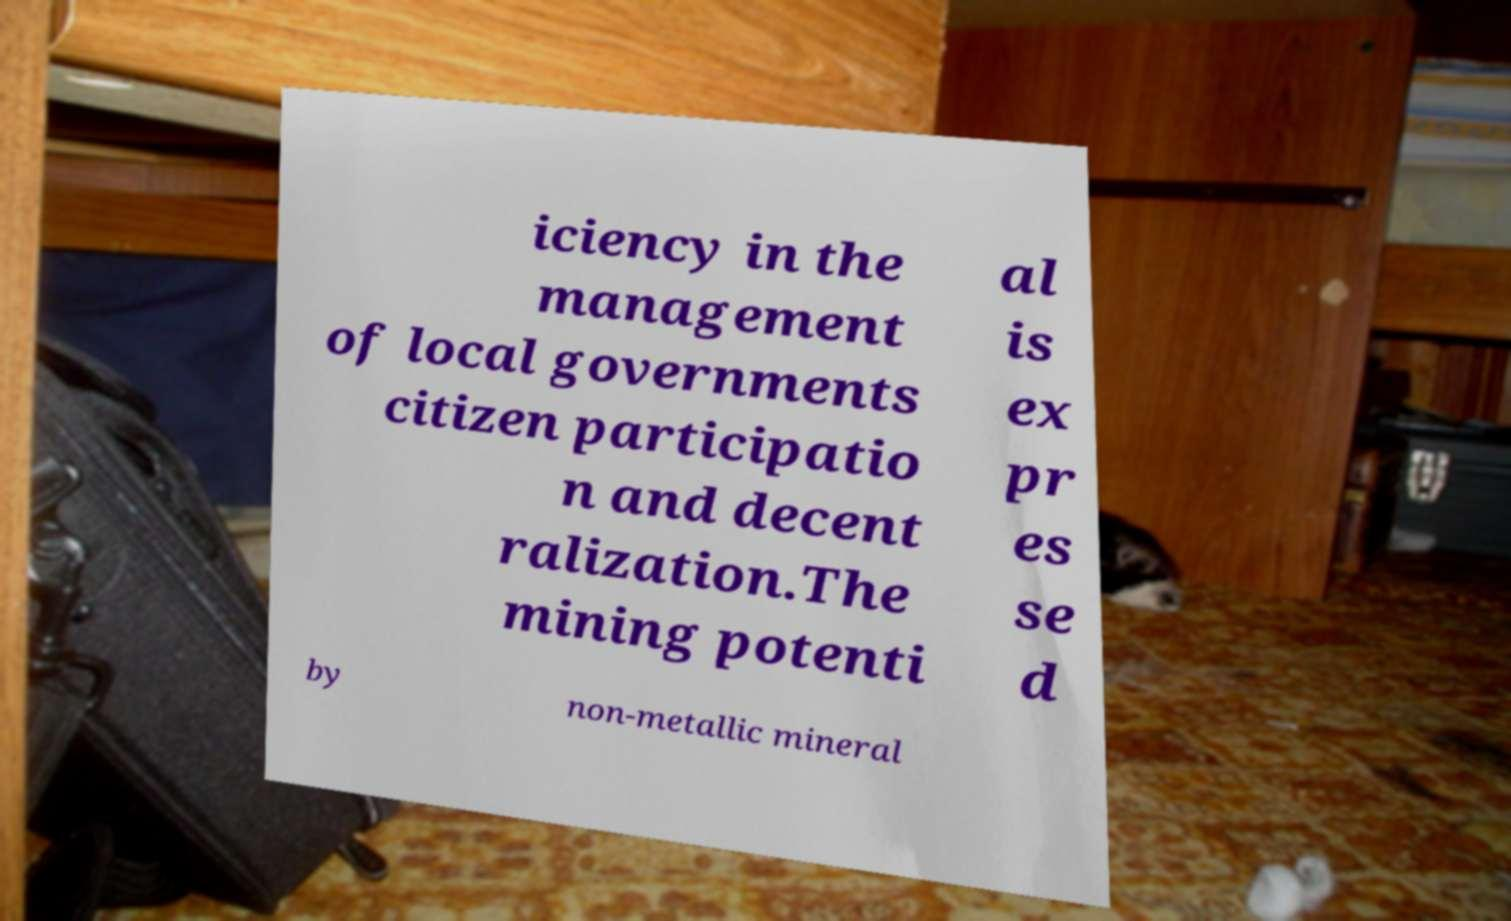Can you accurately transcribe the text from the provided image for me? iciency in the management of local governments citizen participatio n and decent ralization.The mining potenti al is ex pr es se d by non-metallic mineral 